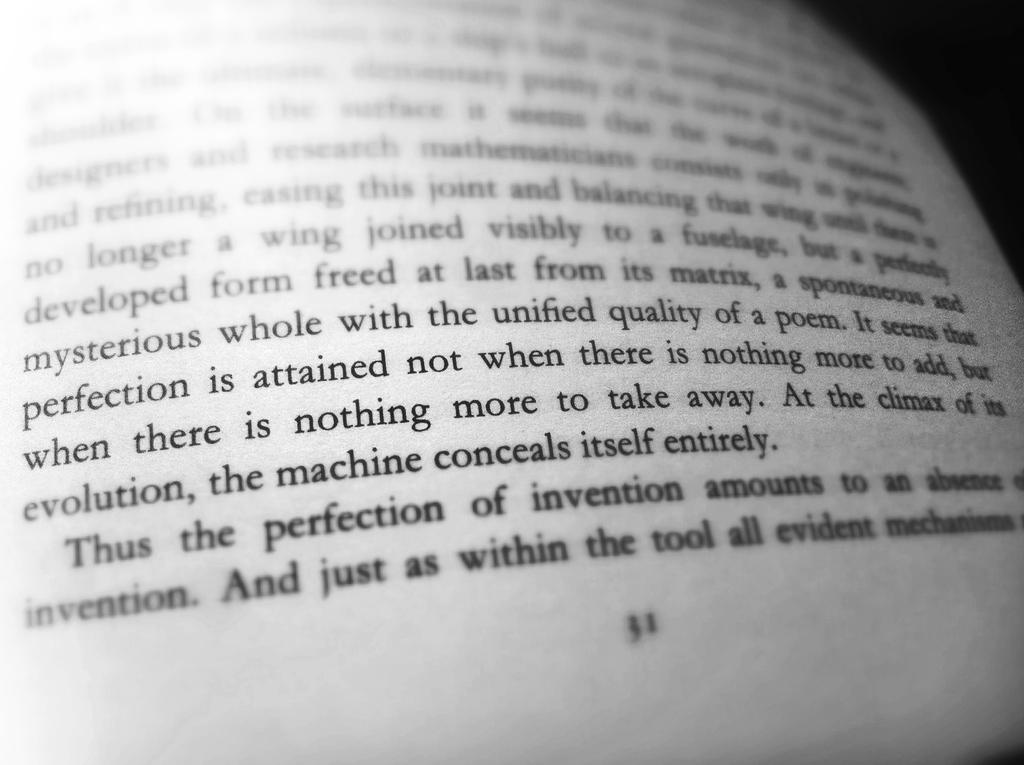<image>
Summarize the visual content of the image. A written page from a book that is on page 31. 